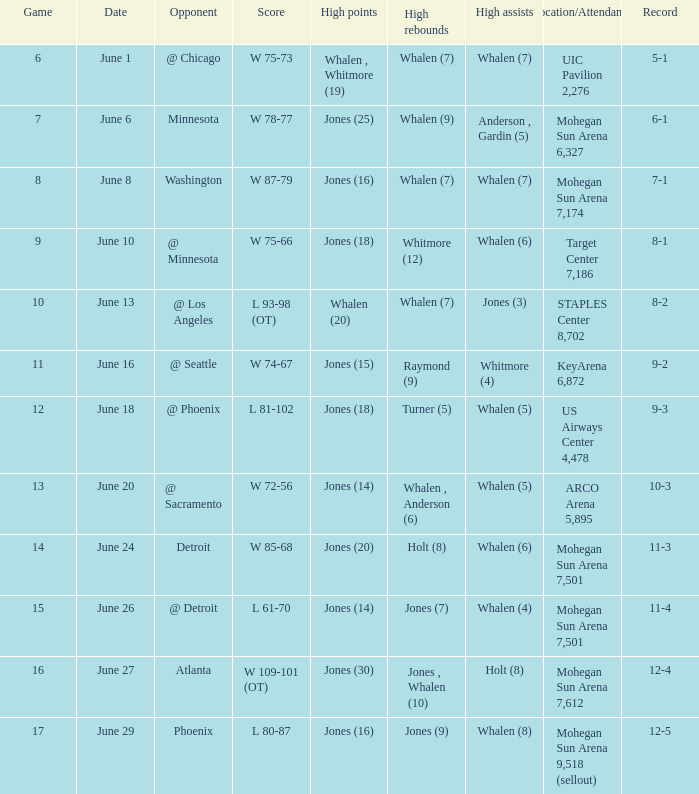Who had the high assists when the game was less than 13 and the score was w 75-66? Whalen (6). 